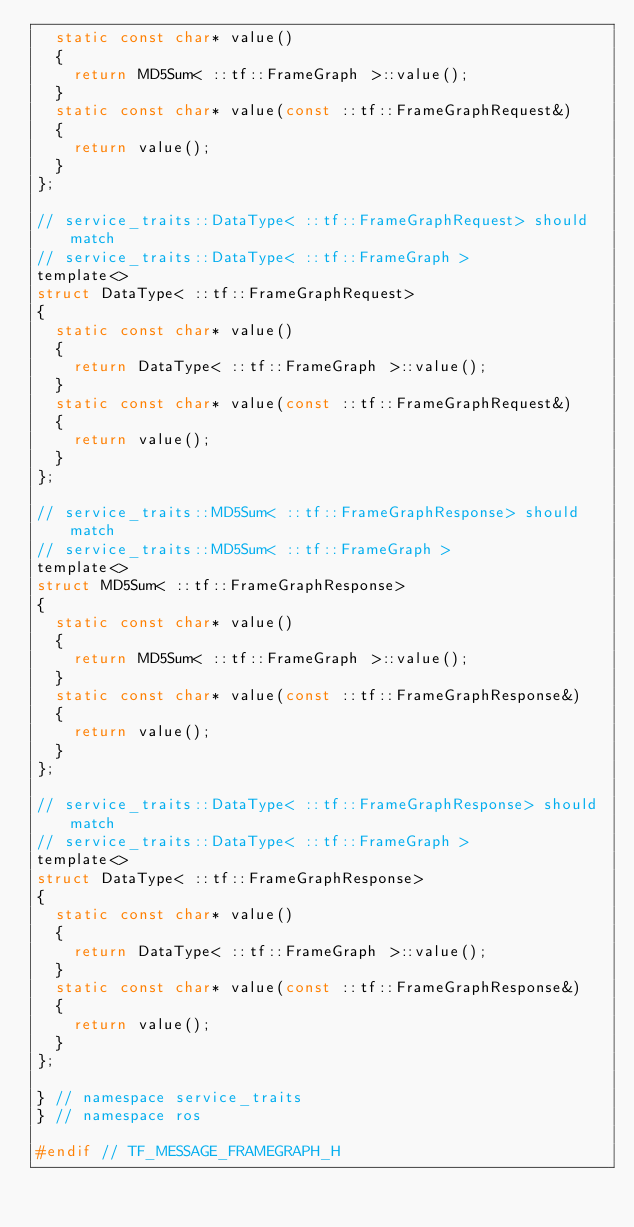Convert code to text. <code><loc_0><loc_0><loc_500><loc_500><_C_>  static const char* value()
  {
    return MD5Sum< ::tf::FrameGraph >::value();
  }
  static const char* value(const ::tf::FrameGraphRequest&)
  {
    return value();
  }
};

// service_traits::DataType< ::tf::FrameGraphRequest> should match
// service_traits::DataType< ::tf::FrameGraph >
template<>
struct DataType< ::tf::FrameGraphRequest>
{
  static const char* value()
  {
    return DataType< ::tf::FrameGraph >::value();
  }
  static const char* value(const ::tf::FrameGraphRequest&)
  {
    return value();
  }
};

// service_traits::MD5Sum< ::tf::FrameGraphResponse> should match
// service_traits::MD5Sum< ::tf::FrameGraph >
template<>
struct MD5Sum< ::tf::FrameGraphResponse>
{
  static const char* value()
  {
    return MD5Sum< ::tf::FrameGraph >::value();
  }
  static const char* value(const ::tf::FrameGraphResponse&)
  {
    return value();
  }
};

// service_traits::DataType< ::tf::FrameGraphResponse> should match
// service_traits::DataType< ::tf::FrameGraph >
template<>
struct DataType< ::tf::FrameGraphResponse>
{
  static const char* value()
  {
    return DataType< ::tf::FrameGraph >::value();
  }
  static const char* value(const ::tf::FrameGraphResponse&)
  {
    return value();
  }
};

} // namespace service_traits
} // namespace ros

#endif // TF_MESSAGE_FRAMEGRAPH_H
</code> 